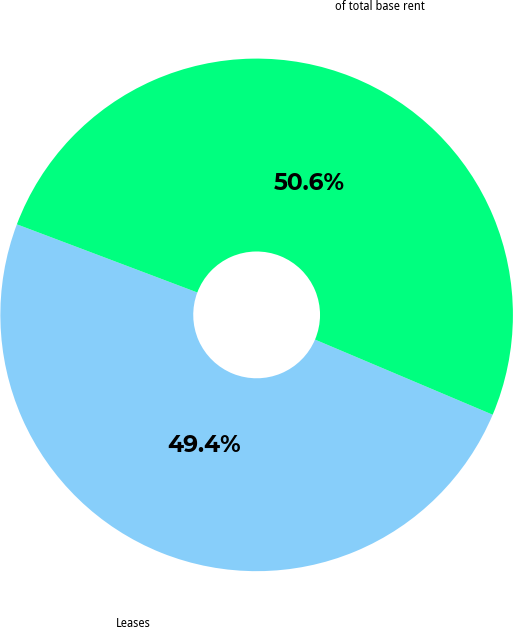Convert chart. <chart><loc_0><loc_0><loc_500><loc_500><pie_chart><fcel>Leases<fcel>of total base rent<nl><fcel>49.38%<fcel>50.62%<nl></chart> 